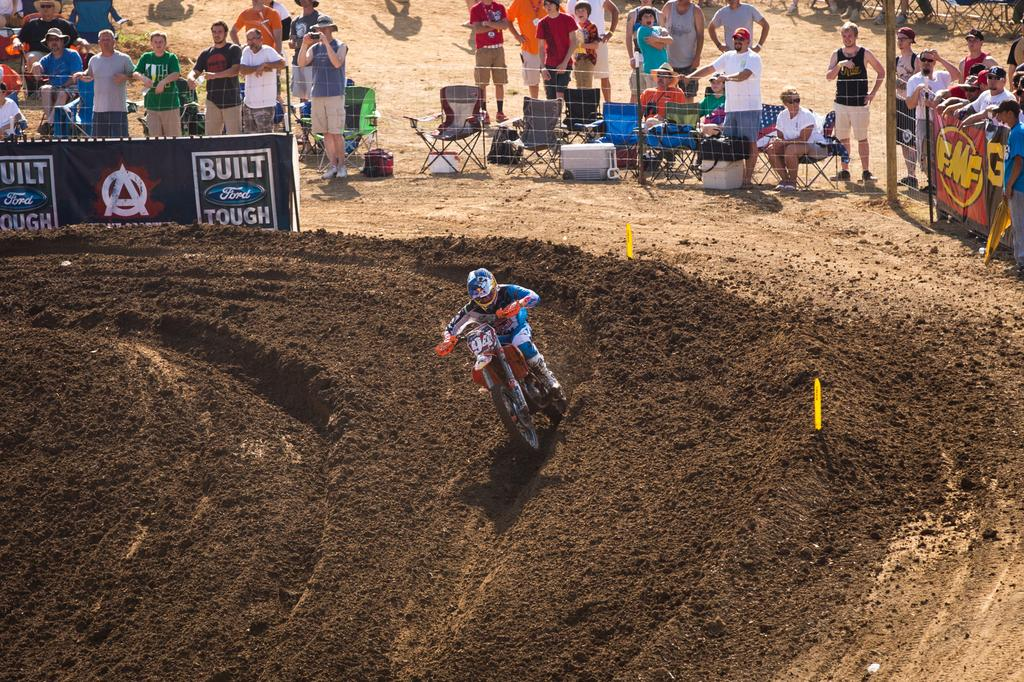What is the main subject of the image? The main subject of the image is a person riding a sports bike. What are the people observing in the image doing? The people observing the person riding the sports bike are standing on one side. What type of way is the person riding the sports bike using in the image? There is no specific type of way mentioned in the image, as it only shows a person riding a sports bike. Can you tell me how many pigs are present in the image? There are no pigs present in the image. 